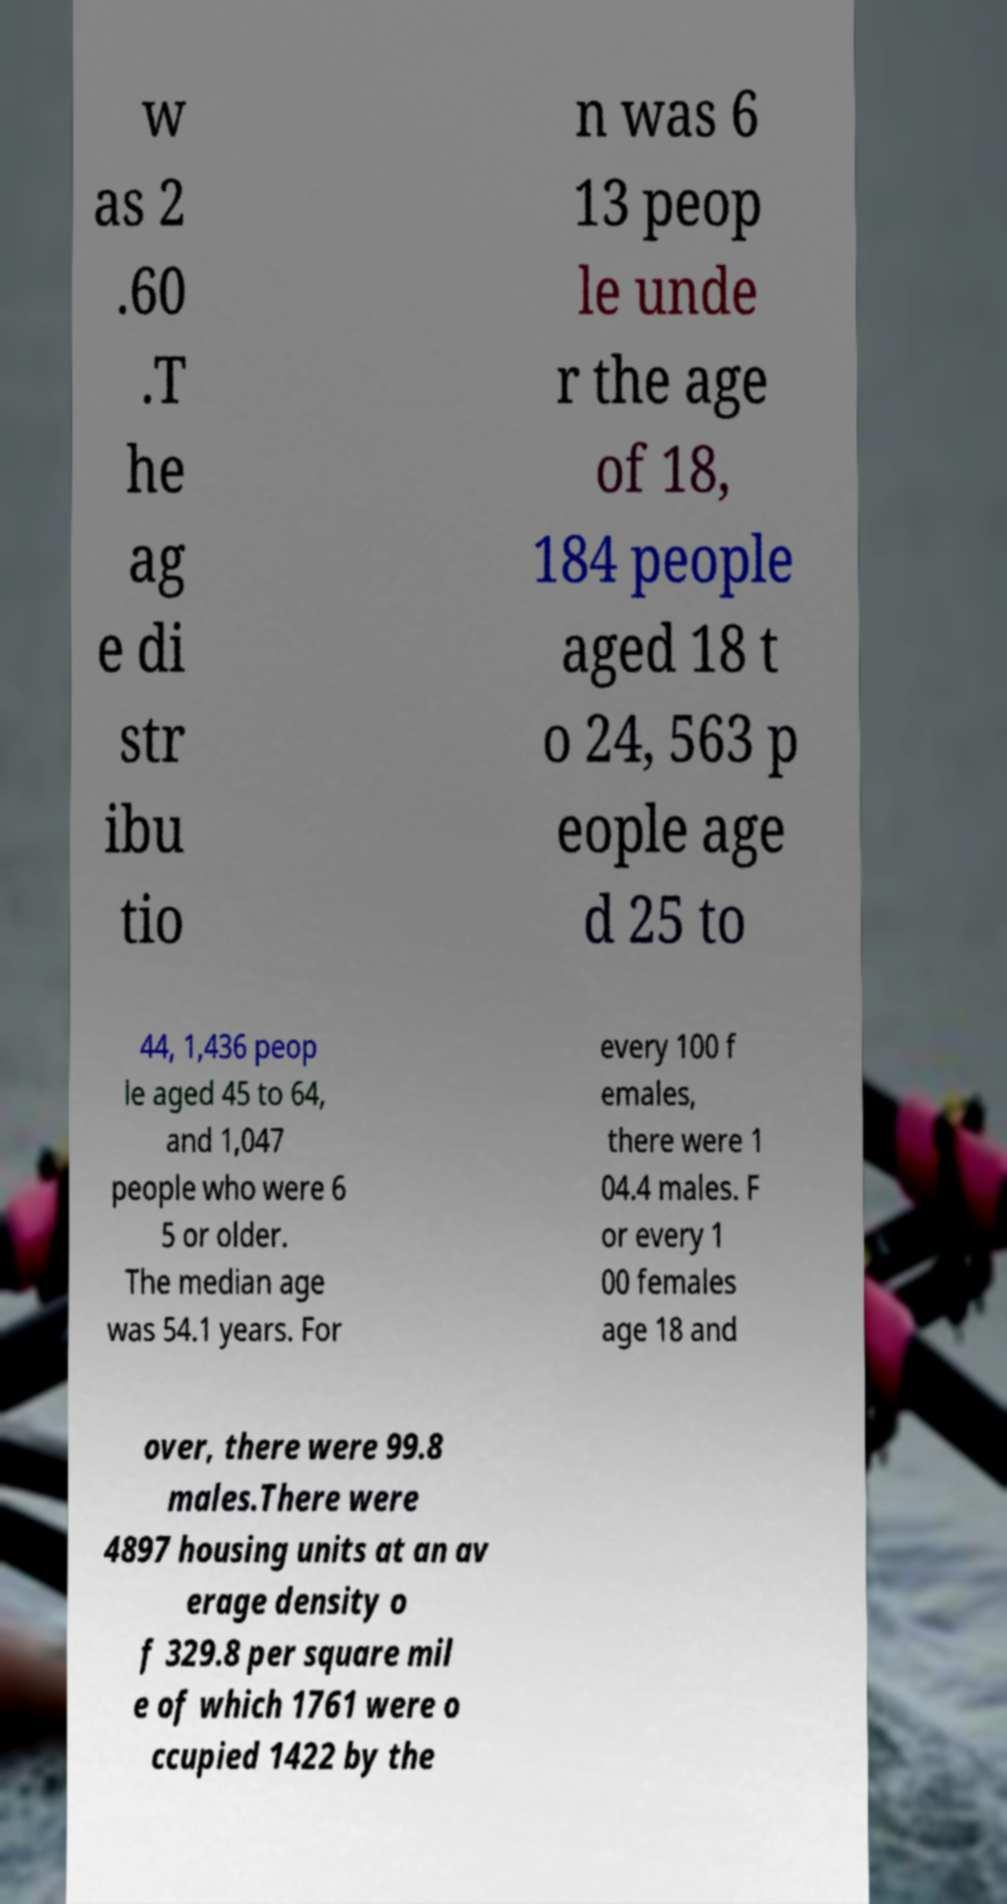I need the written content from this picture converted into text. Can you do that? w as 2 .60 .T he ag e di str ibu tio n was 6 13 peop le unde r the age of 18, 184 people aged 18 t o 24, 563 p eople age d 25 to 44, 1,436 peop le aged 45 to 64, and 1,047 people who were 6 5 or older. The median age was 54.1 years. For every 100 f emales, there were 1 04.4 males. F or every 1 00 females age 18 and over, there were 99.8 males.There were 4897 housing units at an av erage density o f 329.8 per square mil e of which 1761 were o ccupied 1422 by the 